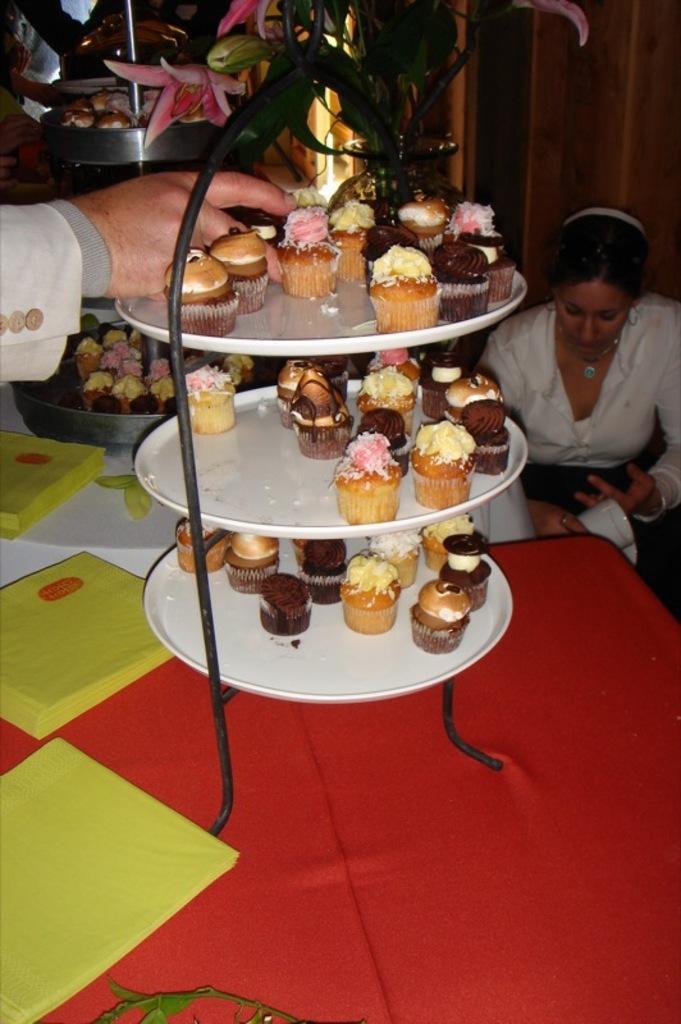Describe this image in one or two sentences. In this image I can see few cupcakes in the plates and I can see the person sitting and the person is wearing white color dress. In front I can see few papers on the red and white color surface. 